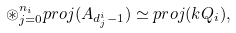Convert formula to latex. <formula><loc_0><loc_0><loc_500><loc_500>\circledast _ { j = 0 } ^ { n _ { i } } p r o j ( A _ { d _ { j } ^ { i } - 1 } ) \simeq p r o j ( k Q _ { i } ) ,</formula> 